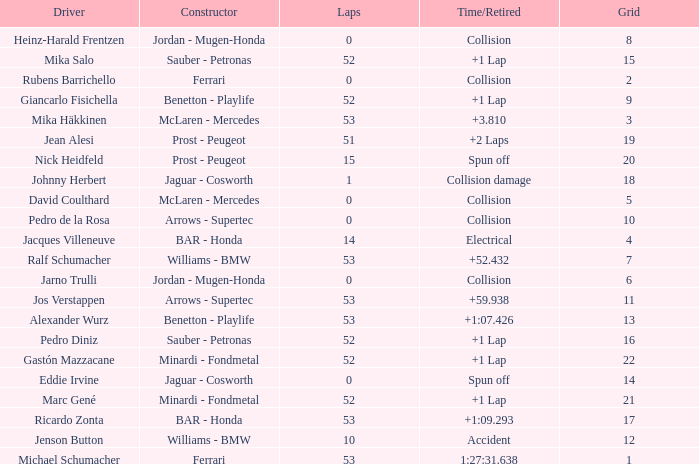What is the grid number with less than 52 laps and a Time/Retired of collision, and a Constructor of arrows - supertec? 1.0. 